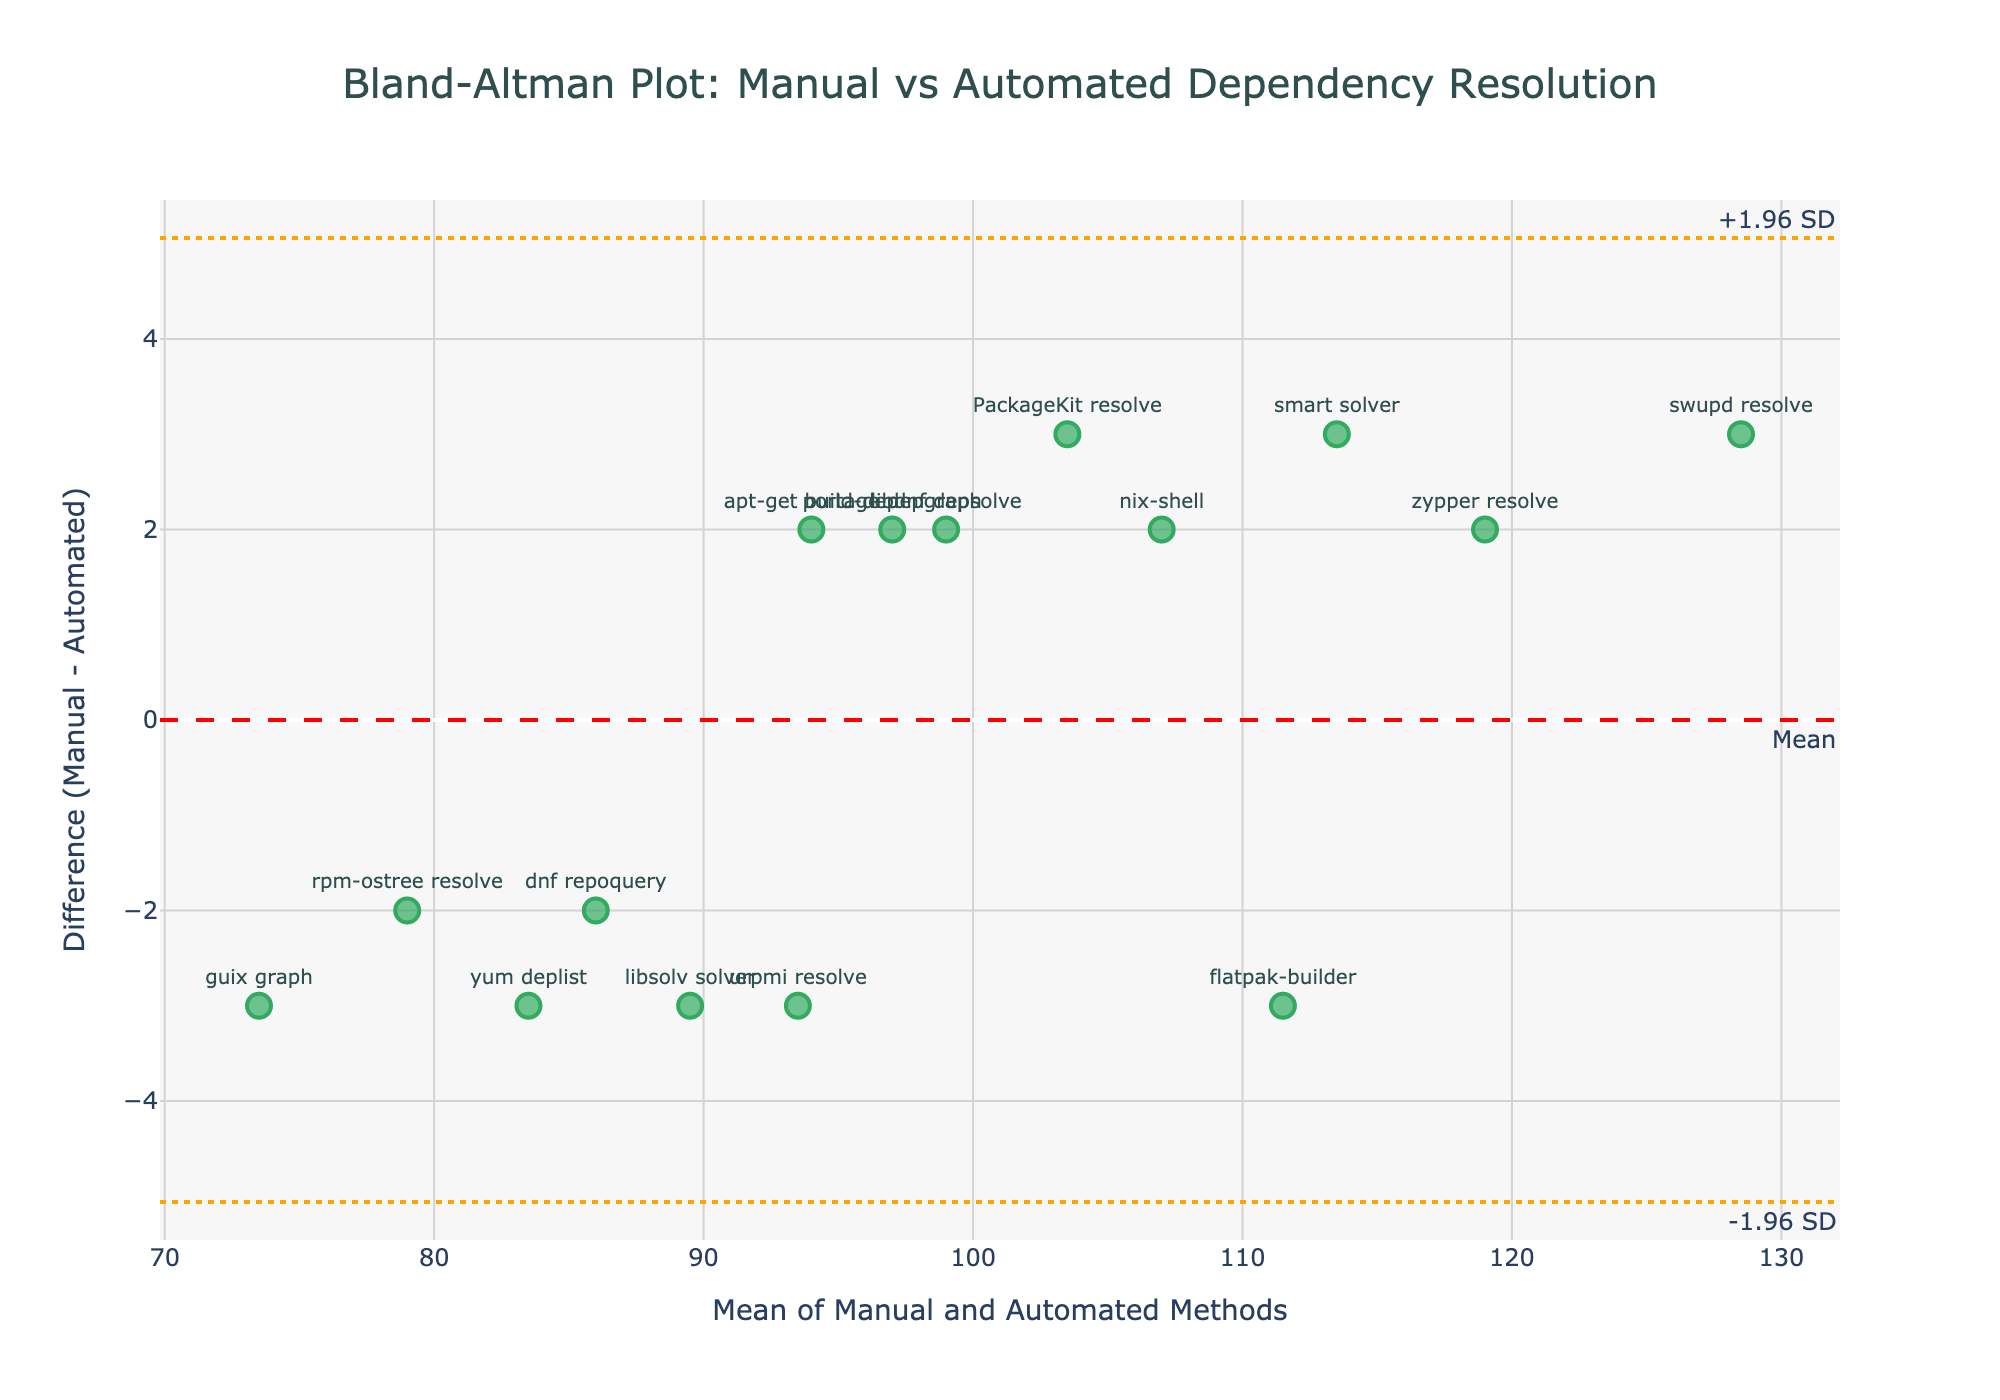What is the title of the plot? The title can be found at the top of the plot. It reads "Bland-Altman Plot: Manual vs Automated Dependency Resolution".
Answer: Bland-Altman Plot: Manual vs Automated Dependency Resolution How many data points are plotted? Each data point represents a comparison between manual and automated methods. Counting them gives 15 data points.
Answer: 15 Which method has the highest mean value? The mean value can be found by averaging the manual and automated values for each method. The method with the highest mean value is "swupd resolve". Mean for "swupd resolve" is (130+127)/2 = 128.5.
Answer: swupd resolve What are the limits of agreement on the plot? The limits of agreement are shown as horizontal dashed lines. The upper limit is +1.96 SD, and the lower limit is -1.96 SD. These lines are marked as orange dashed lines.
Answer: +1.96 SD and -1.96 SD Which methods fall outside the limits of agreement? Methods outside the limits of agreement are those with differences beyond +1.96 SD and -1.96 SD lines. "flatpak-builder" with difference -3 and "zypper resolve" with difference 2 fall outside the limits of agreement.
Answer: flatpak-builder and zypper resolve What's the range of the mean values from the plotted data points? The mean values range is calculated from the minimum to the maximum of the means. The lowest mean is for "guix graph" with (72+75)/2 = 73.5, and the highest mean is for "swupd resolve" with (130+127)/2 = 128.5. Therefore, the range is from 73.5 to 128.5.
Answer: 73.5 to 128.5 What is the mean difference between the manual and automated methods? The mean difference is shown as a horizontal dashed red line marked "Mean" on the plot. The exact value of this line can be read directly as 0.2.
Answer: 0.2 Which data point is closest to the mean difference line? The data point closest to the mean difference line (value 0.2) can be visually estimated. The point "dnf repoquery" with a difference of -2 is close to the mean difference line. Visual inspection indicates "dnf repoquery" is closest.
Answer: dnf repoquery Which method has the largest absolute difference? The largest absolute difference is found by comparing the manual and automated values with their difference absolute value. "flatpak-builder" has the largest absolute difference value of 3 (110 - 113).
Answer: flatpak-builder 